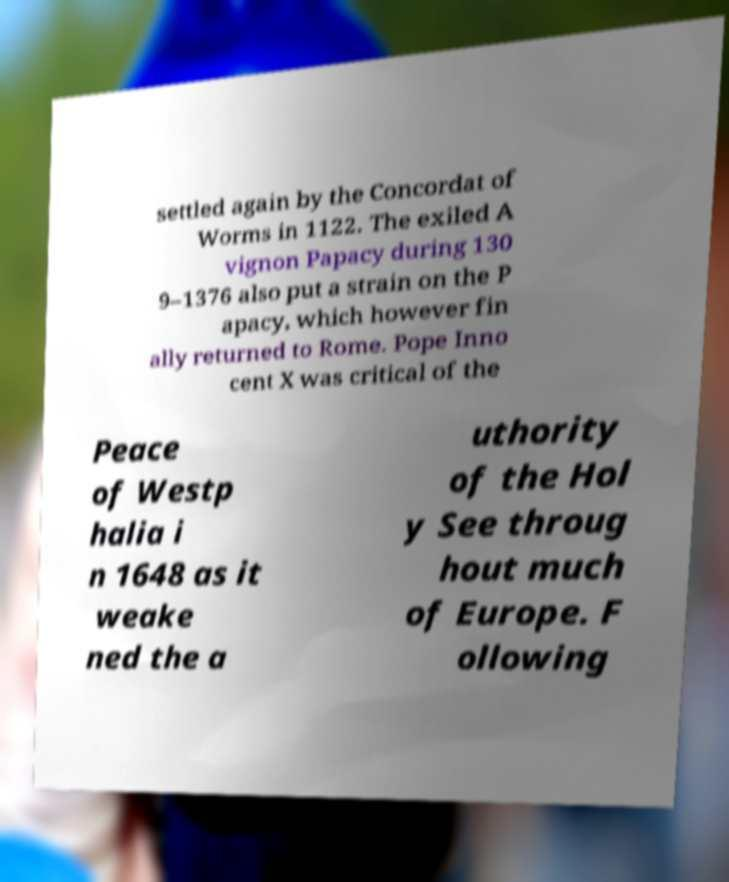Can you read and provide the text displayed in the image?This photo seems to have some interesting text. Can you extract and type it out for me? settled again by the Concordat of Worms in 1122. The exiled A vignon Papacy during 130 9–1376 also put a strain on the P apacy, which however fin ally returned to Rome. Pope Inno cent X was critical of the Peace of Westp halia i n 1648 as it weake ned the a uthority of the Hol y See throug hout much of Europe. F ollowing 